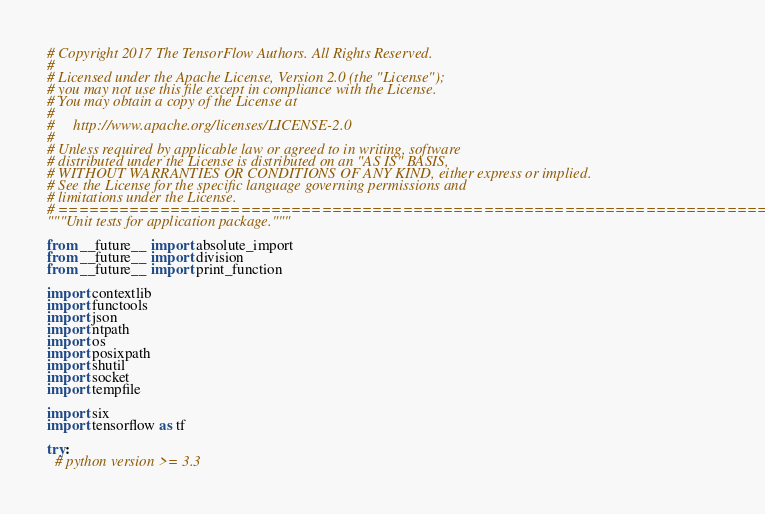<code> <loc_0><loc_0><loc_500><loc_500><_Python_># Copyright 2017 The TensorFlow Authors. All Rights Reserved.
#
# Licensed under the Apache License, Version 2.0 (the "License");
# you may not use this file except in compliance with the License.
# You may obtain a copy of the License at
#
#     http://www.apache.org/licenses/LICENSE-2.0
#
# Unless required by applicable law or agreed to in writing, software
# distributed under the License is distributed on an "AS IS" BASIS,
# WITHOUT WARRANTIES OR CONDITIONS OF ANY KIND, either express or implied.
# See the License for the specific language governing permissions and
# limitations under the License.
# ==============================================================================
"""Unit tests for application package."""

from __future__ import absolute_import
from __future__ import division
from __future__ import print_function

import contextlib
import functools
import json
import ntpath
import os
import posixpath
import shutil
import socket
import tempfile

import six
import tensorflow as tf

try:
  # python version >= 3.3</code> 